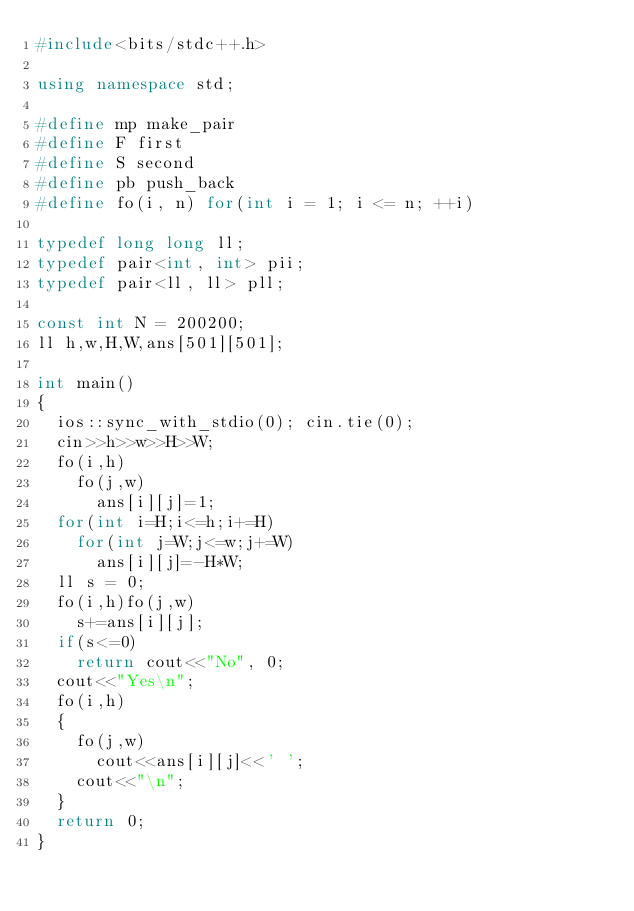Convert code to text. <code><loc_0><loc_0><loc_500><loc_500><_C++_>#include<bits/stdc++.h>

using namespace std;

#define mp make_pair
#define F first
#define S second
#define pb push_back
#define fo(i, n) for(int i = 1; i <= n; ++i)

typedef long long ll;
typedef pair<int, int> pii;
typedef pair<ll, ll> pll;

const int N = 200200;
ll h,w,H,W,ans[501][501];

int main()
{
	ios::sync_with_stdio(0); cin.tie(0);
	cin>>h>>w>>H>>W;
	fo(i,h)
		fo(j,w)
			ans[i][j]=1;	
	for(int i=H;i<=h;i+=H)
		for(int j=W;j<=w;j+=W)
			ans[i][j]=-H*W;
	ll s = 0;
	fo(i,h)fo(j,w)
		s+=ans[i][j];
	if(s<=0)
		return cout<<"No", 0;
	cout<<"Yes\n";
	fo(i,h)
	{
		fo(j,w)
			cout<<ans[i][j]<<' ';
		cout<<"\n";
	}
	return 0;
}
</code> 